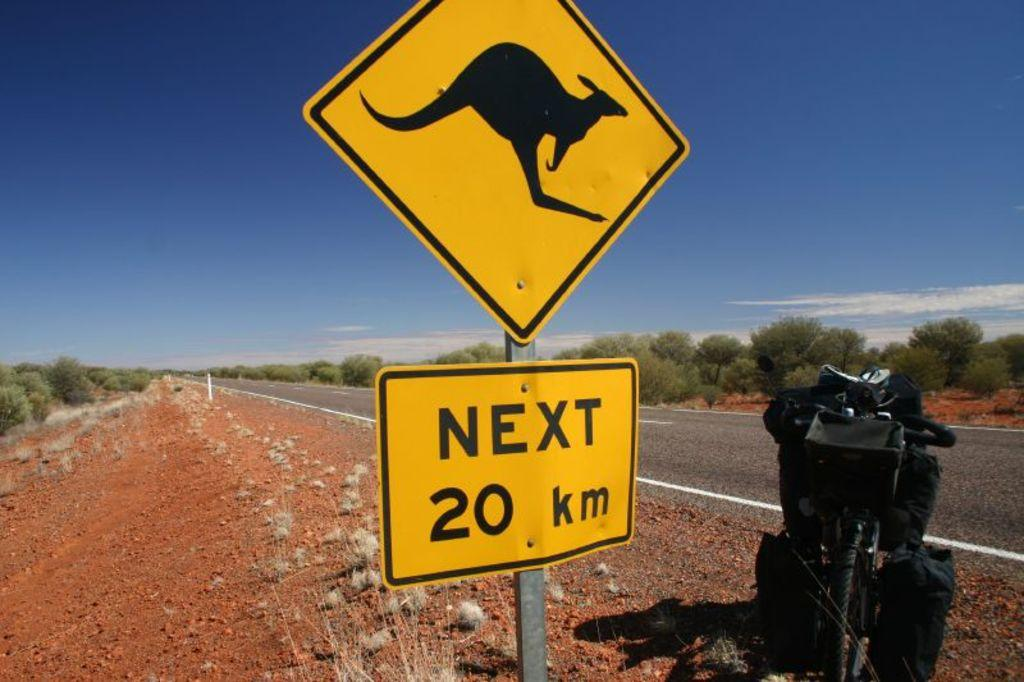What type of objects are present on the sign boards in the image? The sign boards have rods in the image. What can be seen in the background of the image? There is a road, the ground, trees, and the sky visible in the background of the image. Where is the bicycle located in the image? The bicycle is on the right side of the image. What else is present on the right side of the image besides the bicycle? There are additional objects on the right side of the image. How does the growth of the trees affect the comfort of the people in the image? There are no people present in the image, and the growth of the trees does not affect the comfort of any individuals. 